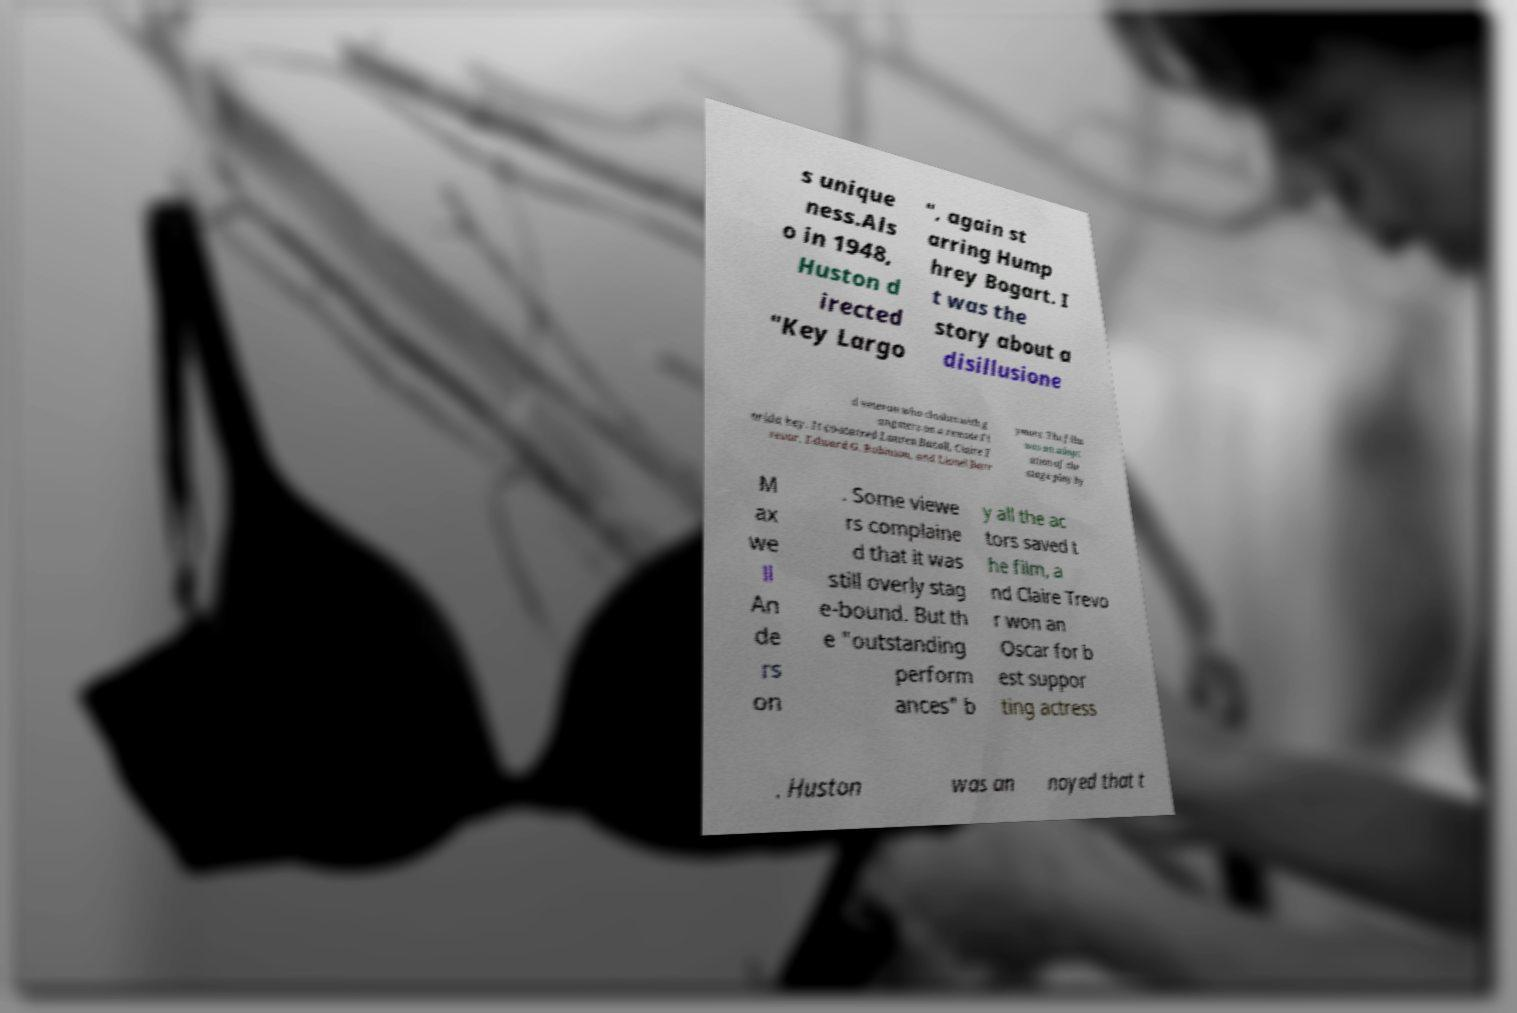For documentation purposes, I need the text within this image transcribed. Could you provide that? s unique ness.Als o in 1948, Huston d irected "Key Largo ", again st arring Hump hrey Bogart. I t was the story about a disillusione d veteran who clashes with g angsters on a remote Fl orida key. It co-starred Lauren Bacall, Claire T revor, Edward G. Robinson, and Lionel Barr ymore. The film was an adapt ation of the stage play by M ax we ll An de rs on . Some viewe rs complaine d that it was still overly stag e-bound. But th e "outstanding perform ances" b y all the ac tors saved t he film, a nd Claire Trevo r won an Oscar for b est suppor ting actress . Huston was an noyed that t 